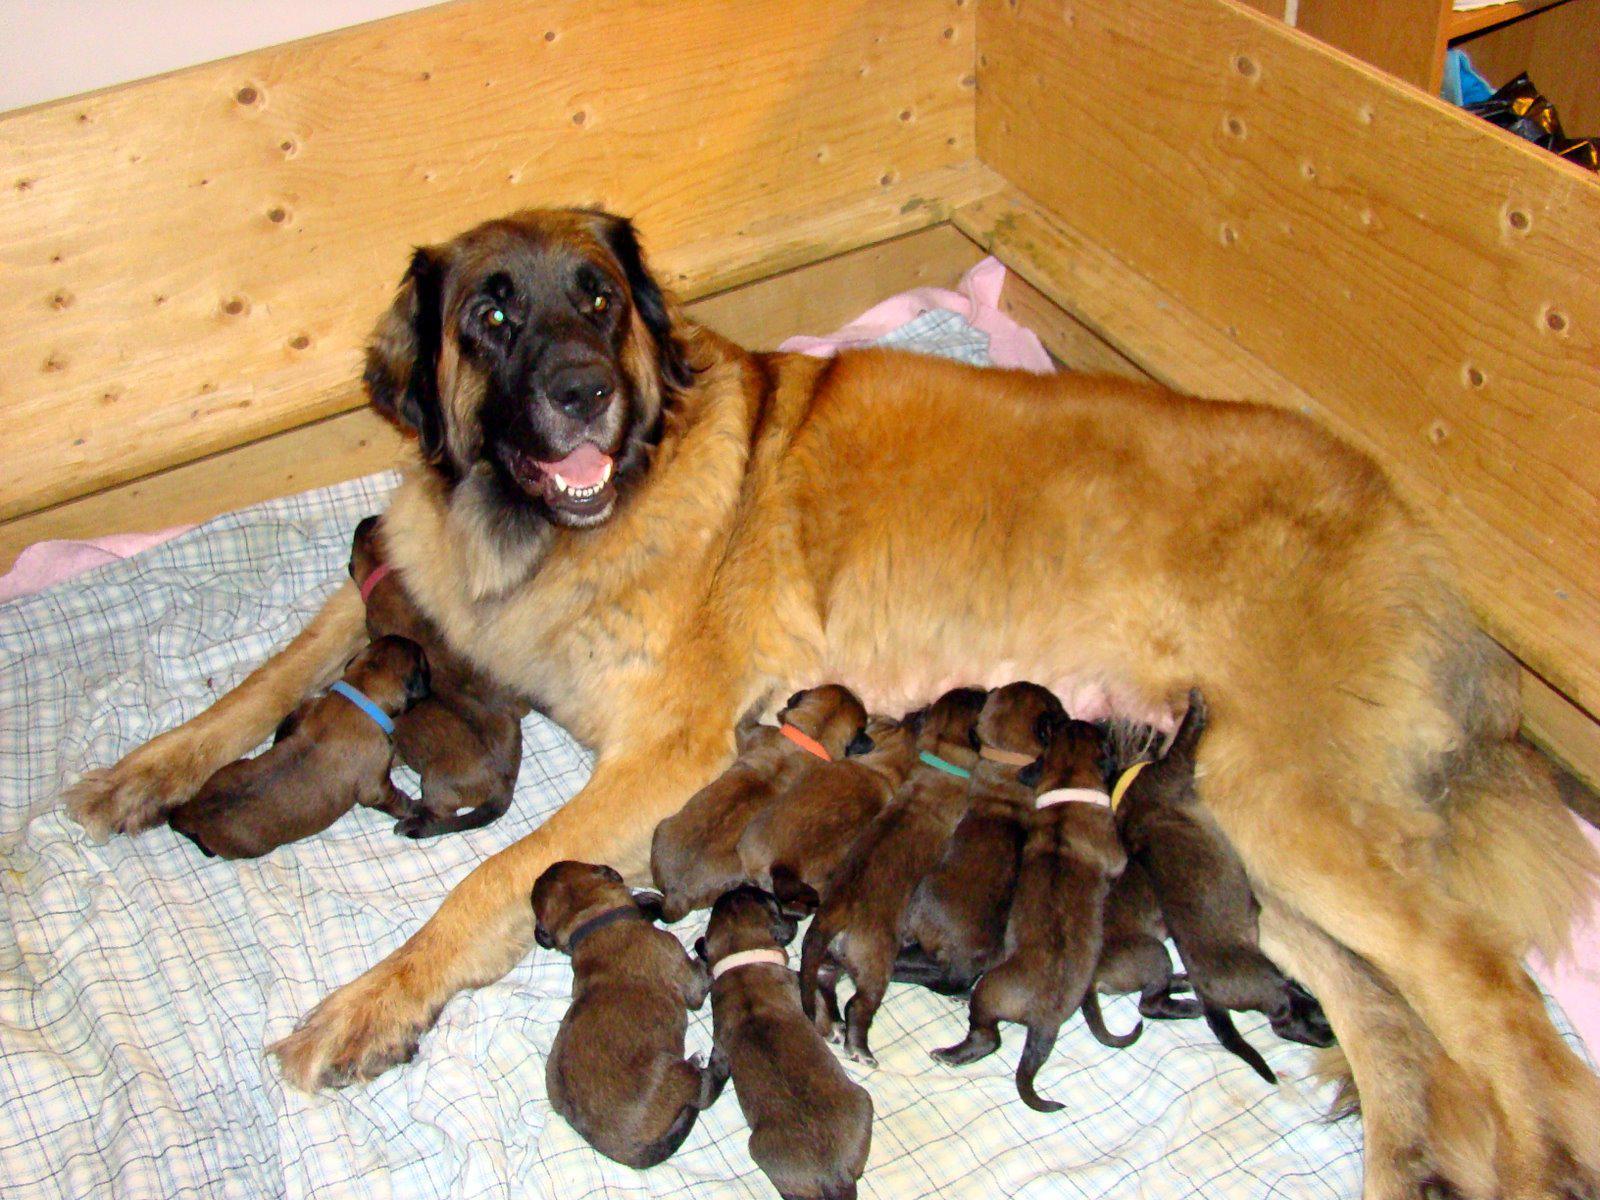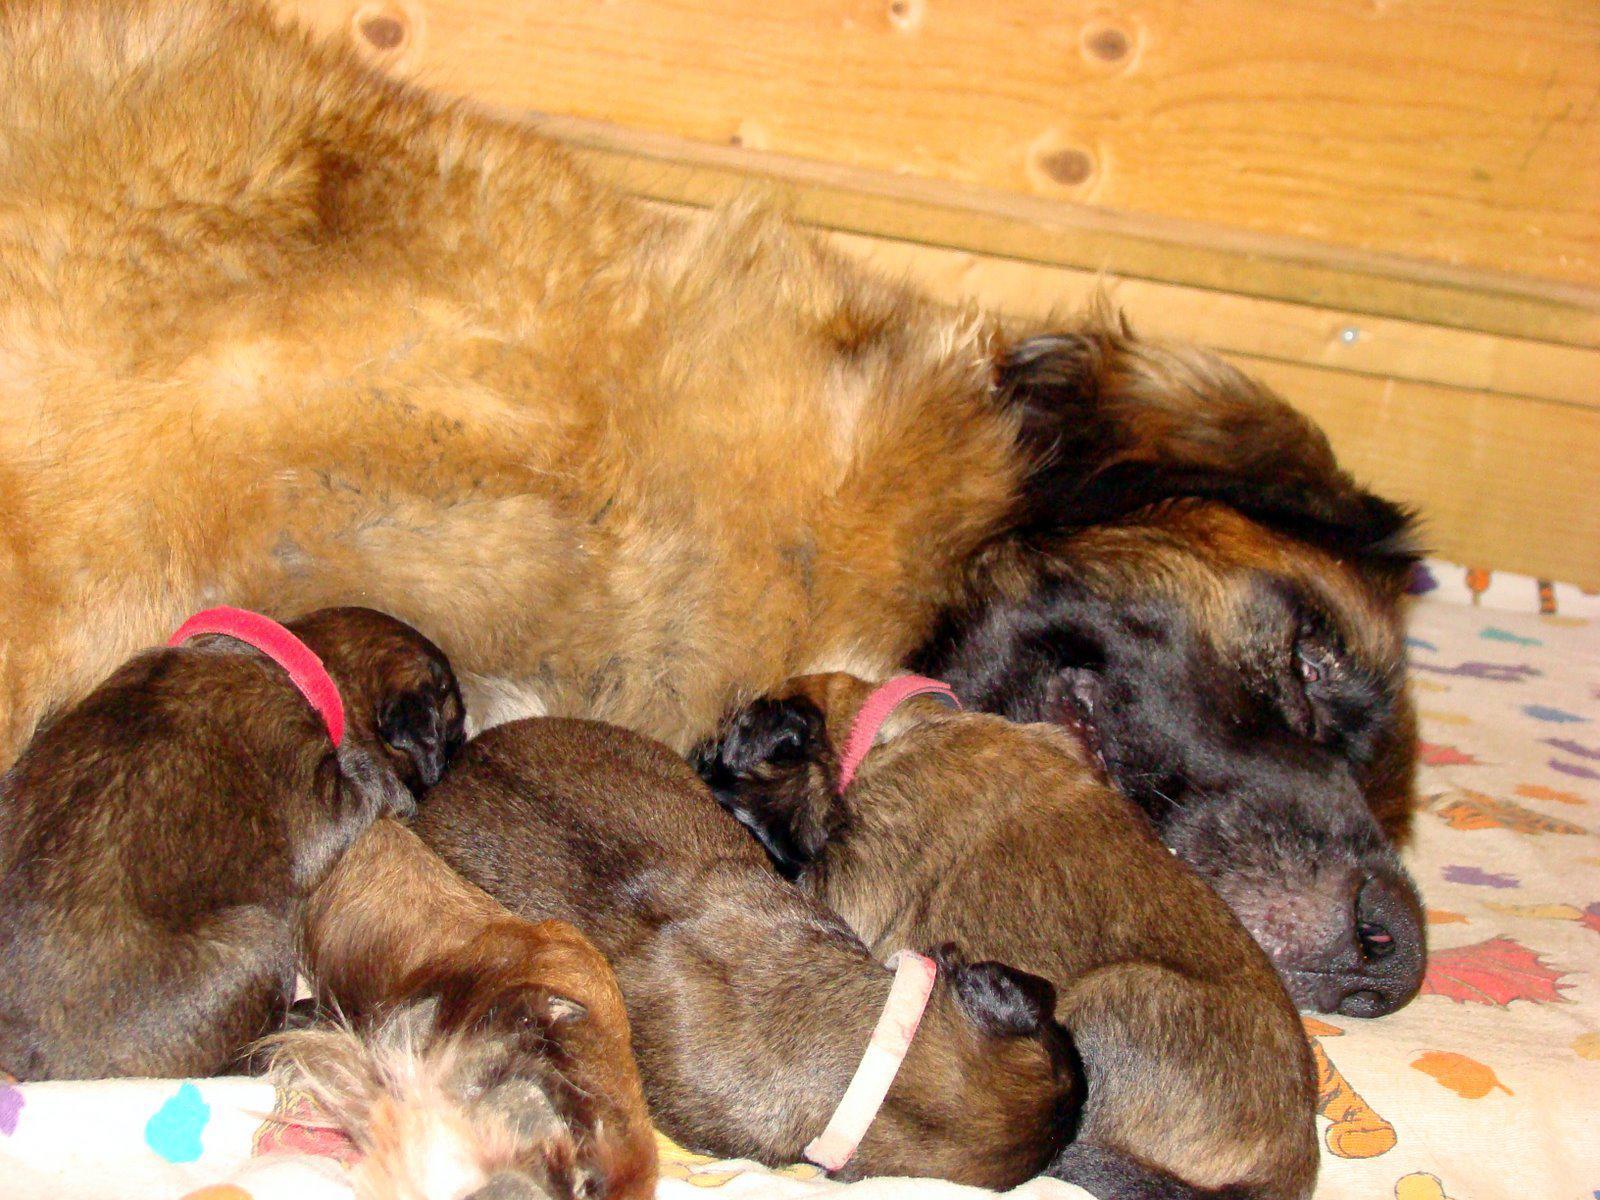The first image is the image on the left, the second image is the image on the right. Examine the images to the left and right. Is the description "Puppies are nursing on a puppy paw print rug in one of the images." accurate? Answer yes or no. No. The first image is the image on the left, the second image is the image on the right. Analyze the images presented: Is the assertion "An image shows multiple puppies on a gray rug with a paw print pattern." valid? Answer yes or no. No. 